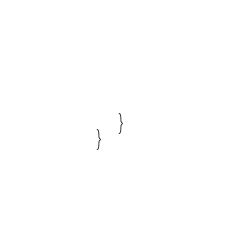Convert code to text. <code><loc_0><loc_0><loc_500><loc_500><_C++_>		
	}
}
</code> 